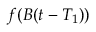Convert formula to latex. <formula><loc_0><loc_0><loc_500><loc_500>f ( B ( t - T _ { 1 } ) )</formula> 